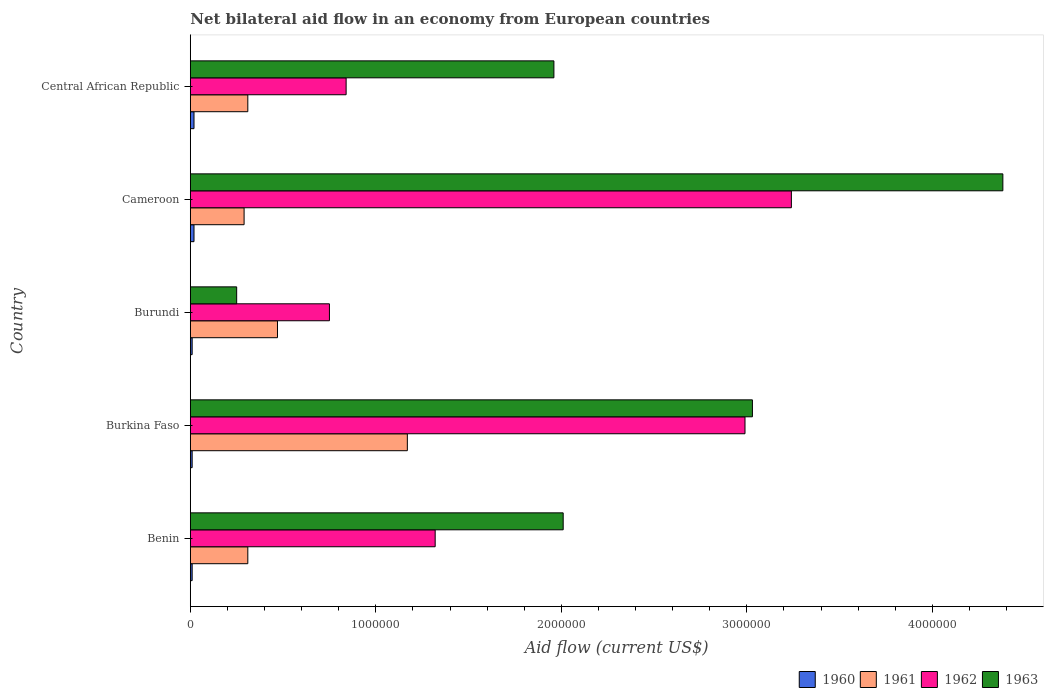How many groups of bars are there?
Keep it short and to the point. 5. Are the number of bars on each tick of the Y-axis equal?
Give a very brief answer. Yes. How many bars are there on the 2nd tick from the top?
Offer a terse response. 4. How many bars are there on the 1st tick from the bottom?
Offer a terse response. 4. What is the label of the 1st group of bars from the top?
Offer a very short reply. Central African Republic. What is the net bilateral aid flow in 1963 in Central African Republic?
Ensure brevity in your answer.  1.96e+06. In which country was the net bilateral aid flow in 1961 maximum?
Keep it short and to the point. Burkina Faso. In which country was the net bilateral aid flow in 1961 minimum?
Provide a succinct answer. Cameroon. What is the total net bilateral aid flow in 1961 in the graph?
Your answer should be very brief. 2.55e+06. What is the difference between the net bilateral aid flow in 1963 in Benin and that in Burundi?
Make the answer very short. 1.76e+06. What is the difference between the net bilateral aid flow in 1961 in Benin and the net bilateral aid flow in 1963 in Central African Republic?
Offer a very short reply. -1.65e+06. What is the average net bilateral aid flow in 1962 per country?
Your answer should be compact. 1.83e+06. What is the ratio of the net bilateral aid flow in 1962 in Benin to that in Cameroon?
Offer a terse response. 0.41. Is the net bilateral aid flow in 1960 in Benin less than that in Cameroon?
Give a very brief answer. Yes. Is the difference between the net bilateral aid flow in 1963 in Benin and Burkina Faso greater than the difference between the net bilateral aid flow in 1960 in Benin and Burkina Faso?
Offer a very short reply. No. What is the difference between the highest and the second highest net bilateral aid flow in 1963?
Provide a short and direct response. 1.35e+06. What is the difference between the highest and the lowest net bilateral aid flow in 1961?
Your answer should be compact. 8.80e+05. Is it the case that in every country, the sum of the net bilateral aid flow in 1963 and net bilateral aid flow in 1960 is greater than the sum of net bilateral aid flow in 1961 and net bilateral aid flow in 1962?
Your answer should be very brief. Yes. How many bars are there?
Your answer should be compact. 20. Are the values on the major ticks of X-axis written in scientific E-notation?
Give a very brief answer. No. Does the graph contain any zero values?
Provide a short and direct response. No. What is the title of the graph?
Provide a succinct answer. Net bilateral aid flow in an economy from European countries. What is the label or title of the X-axis?
Provide a succinct answer. Aid flow (current US$). What is the label or title of the Y-axis?
Offer a terse response. Country. What is the Aid flow (current US$) of 1961 in Benin?
Give a very brief answer. 3.10e+05. What is the Aid flow (current US$) of 1962 in Benin?
Make the answer very short. 1.32e+06. What is the Aid flow (current US$) of 1963 in Benin?
Ensure brevity in your answer.  2.01e+06. What is the Aid flow (current US$) of 1961 in Burkina Faso?
Provide a succinct answer. 1.17e+06. What is the Aid flow (current US$) in 1962 in Burkina Faso?
Your response must be concise. 2.99e+06. What is the Aid flow (current US$) of 1963 in Burkina Faso?
Offer a very short reply. 3.03e+06. What is the Aid flow (current US$) in 1962 in Burundi?
Provide a succinct answer. 7.50e+05. What is the Aid flow (current US$) of 1963 in Burundi?
Your response must be concise. 2.50e+05. What is the Aid flow (current US$) in 1962 in Cameroon?
Your response must be concise. 3.24e+06. What is the Aid flow (current US$) of 1963 in Cameroon?
Offer a very short reply. 4.38e+06. What is the Aid flow (current US$) of 1960 in Central African Republic?
Your answer should be very brief. 2.00e+04. What is the Aid flow (current US$) in 1962 in Central African Republic?
Your response must be concise. 8.40e+05. What is the Aid flow (current US$) of 1963 in Central African Republic?
Keep it short and to the point. 1.96e+06. Across all countries, what is the maximum Aid flow (current US$) of 1960?
Provide a short and direct response. 2.00e+04. Across all countries, what is the maximum Aid flow (current US$) in 1961?
Keep it short and to the point. 1.17e+06. Across all countries, what is the maximum Aid flow (current US$) of 1962?
Provide a succinct answer. 3.24e+06. Across all countries, what is the maximum Aid flow (current US$) in 1963?
Offer a terse response. 4.38e+06. Across all countries, what is the minimum Aid flow (current US$) of 1960?
Offer a very short reply. 10000. Across all countries, what is the minimum Aid flow (current US$) of 1961?
Provide a succinct answer. 2.90e+05. Across all countries, what is the minimum Aid flow (current US$) in 1962?
Your response must be concise. 7.50e+05. Across all countries, what is the minimum Aid flow (current US$) in 1963?
Make the answer very short. 2.50e+05. What is the total Aid flow (current US$) in 1961 in the graph?
Offer a very short reply. 2.55e+06. What is the total Aid flow (current US$) of 1962 in the graph?
Your answer should be very brief. 9.14e+06. What is the total Aid flow (current US$) in 1963 in the graph?
Provide a short and direct response. 1.16e+07. What is the difference between the Aid flow (current US$) in 1961 in Benin and that in Burkina Faso?
Make the answer very short. -8.60e+05. What is the difference between the Aid flow (current US$) in 1962 in Benin and that in Burkina Faso?
Offer a very short reply. -1.67e+06. What is the difference between the Aid flow (current US$) of 1963 in Benin and that in Burkina Faso?
Your answer should be very brief. -1.02e+06. What is the difference between the Aid flow (current US$) of 1960 in Benin and that in Burundi?
Give a very brief answer. 0. What is the difference between the Aid flow (current US$) in 1962 in Benin and that in Burundi?
Offer a very short reply. 5.70e+05. What is the difference between the Aid flow (current US$) in 1963 in Benin and that in Burundi?
Provide a succinct answer. 1.76e+06. What is the difference between the Aid flow (current US$) of 1961 in Benin and that in Cameroon?
Your answer should be very brief. 2.00e+04. What is the difference between the Aid flow (current US$) of 1962 in Benin and that in Cameroon?
Make the answer very short. -1.92e+06. What is the difference between the Aid flow (current US$) of 1963 in Benin and that in Cameroon?
Your answer should be very brief. -2.37e+06. What is the difference between the Aid flow (current US$) in 1960 in Benin and that in Central African Republic?
Make the answer very short. -10000. What is the difference between the Aid flow (current US$) in 1963 in Benin and that in Central African Republic?
Offer a very short reply. 5.00e+04. What is the difference between the Aid flow (current US$) in 1962 in Burkina Faso and that in Burundi?
Make the answer very short. 2.24e+06. What is the difference between the Aid flow (current US$) in 1963 in Burkina Faso and that in Burundi?
Offer a terse response. 2.78e+06. What is the difference between the Aid flow (current US$) of 1960 in Burkina Faso and that in Cameroon?
Offer a terse response. -10000. What is the difference between the Aid flow (current US$) of 1961 in Burkina Faso and that in Cameroon?
Offer a very short reply. 8.80e+05. What is the difference between the Aid flow (current US$) in 1962 in Burkina Faso and that in Cameroon?
Offer a terse response. -2.50e+05. What is the difference between the Aid flow (current US$) in 1963 in Burkina Faso and that in Cameroon?
Offer a terse response. -1.35e+06. What is the difference between the Aid flow (current US$) in 1960 in Burkina Faso and that in Central African Republic?
Provide a short and direct response. -10000. What is the difference between the Aid flow (current US$) of 1961 in Burkina Faso and that in Central African Republic?
Offer a very short reply. 8.60e+05. What is the difference between the Aid flow (current US$) in 1962 in Burkina Faso and that in Central African Republic?
Make the answer very short. 2.15e+06. What is the difference between the Aid flow (current US$) of 1963 in Burkina Faso and that in Central African Republic?
Your answer should be compact. 1.07e+06. What is the difference between the Aid flow (current US$) in 1962 in Burundi and that in Cameroon?
Provide a succinct answer. -2.49e+06. What is the difference between the Aid flow (current US$) in 1963 in Burundi and that in Cameroon?
Your answer should be compact. -4.13e+06. What is the difference between the Aid flow (current US$) of 1960 in Burundi and that in Central African Republic?
Make the answer very short. -10000. What is the difference between the Aid flow (current US$) in 1961 in Burundi and that in Central African Republic?
Provide a succinct answer. 1.60e+05. What is the difference between the Aid flow (current US$) in 1963 in Burundi and that in Central African Republic?
Ensure brevity in your answer.  -1.71e+06. What is the difference between the Aid flow (current US$) of 1960 in Cameroon and that in Central African Republic?
Provide a succinct answer. 0. What is the difference between the Aid flow (current US$) of 1962 in Cameroon and that in Central African Republic?
Offer a very short reply. 2.40e+06. What is the difference between the Aid flow (current US$) of 1963 in Cameroon and that in Central African Republic?
Keep it short and to the point. 2.42e+06. What is the difference between the Aid flow (current US$) of 1960 in Benin and the Aid flow (current US$) of 1961 in Burkina Faso?
Offer a very short reply. -1.16e+06. What is the difference between the Aid flow (current US$) of 1960 in Benin and the Aid flow (current US$) of 1962 in Burkina Faso?
Make the answer very short. -2.98e+06. What is the difference between the Aid flow (current US$) of 1960 in Benin and the Aid flow (current US$) of 1963 in Burkina Faso?
Provide a succinct answer. -3.02e+06. What is the difference between the Aid flow (current US$) in 1961 in Benin and the Aid flow (current US$) in 1962 in Burkina Faso?
Keep it short and to the point. -2.68e+06. What is the difference between the Aid flow (current US$) in 1961 in Benin and the Aid flow (current US$) in 1963 in Burkina Faso?
Make the answer very short. -2.72e+06. What is the difference between the Aid flow (current US$) in 1962 in Benin and the Aid flow (current US$) in 1963 in Burkina Faso?
Make the answer very short. -1.71e+06. What is the difference between the Aid flow (current US$) of 1960 in Benin and the Aid flow (current US$) of 1961 in Burundi?
Your response must be concise. -4.60e+05. What is the difference between the Aid flow (current US$) of 1960 in Benin and the Aid flow (current US$) of 1962 in Burundi?
Offer a terse response. -7.40e+05. What is the difference between the Aid flow (current US$) of 1961 in Benin and the Aid flow (current US$) of 1962 in Burundi?
Provide a succinct answer. -4.40e+05. What is the difference between the Aid flow (current US$) of 1962 in Benin and the Aid flow (current US$) of 1963 in Burundi?
Provide a short and direct response. 1.07e+06. What is the difference between the Aid flow (current US$) in 1960 in Benin and the Aid flow (current US$) in 1961 in Cameroon?
Keep it short and to the point. -2.80e+05. What is the difference between the Aid flow (current US$) in 1960 in Benin and the Aid flow (current US$) in 1962 in Cameroon?
Your answer should be very brief. -3.23e+06. What is the difference between the Aid flow (current US$) of 1960 in Benin and the Aid flow (current US$) of 1963 in Cameroon?
Make the answer very short. -4.37e+06. What is the difference between the Aid flow (current US$) of 1961 in Benin and the Aid flow (current US$) of 1962 in Cameroon?
Provide a short and direct response. -2.93e+06. What is the difference between the Aid flow (current US$) in 1961 in Benin and the Aid flow (current US$) in 1963 in Cameroon?
Offer a terse response. -4.07e+06. What is the difference between the Aid flow (current US$) of 1962 in Benin and the Aid flow (current US$) of 1963 in Cameroon?
Your answer should be compact. -3.06e+06. What is the difference between the Aid flow (current US$) in 1960 in Benin and the Aid flow (current US$) in 1961 in Central African Republic?
Your answer should be compact. -3.00e+05. What is the difference between the Aid flow (current US$) of 1960 in Benin and the Aid flow (current US$) of 1962 in Central African Republic?
Ensure brevity in your answer.  -8.30e+05. What is the difference between the Aid flow (current US$) of 1960 in Benin and the Aid flow (current US$) of 1963 in Central African Republic?
Make the answer very short. -1.95e+06. What is the difference between the Aid flow (current US$) of 1961 in Benin and the Aid flow (current US$) of 1962 in Central African Republic?
Your answer should be compact. -5.30e+05. What is the difference between the Aid flow (current US$) in 1961 in Benin and the Aid flow (current US$) in 1963 in Central African Republic?
Make the answer very short. -1.65e+06. What is the difference between the Aid flow (current US$) of 1962 in Benin and the Aid flow (current US$) of 1963 in Central African Republic?
Offer a terse response. -6.40e+05. What is the difference between the Aid flow (current US$) in 1960 in Burkina Faso and the Aid flow (current US$) in 1961 in Burundi?
Provide a short and direct response. -4.60e+05. What is the difference between the Aid flow (current US$) in 1960 in Burkina Faso and the Aid flow (current US$) in 1962 in Burundi?
Provide a short and direct response. -7.40e+05. What is the difference between the Aid flow (current US$) of 1960 in Burkina Faso and the Aid flow (current US$) of 1963 in Burundi?
Offer a very short reply. -2.40e+05. What is the difference between the Aid flow (current US$) of 1961 in Burkina Faso and the Aid flow (current US$) of 1962 in Burundi?
Offer a terse response. 4.20e+05. What is the difference between the Aid flow (current US$) in 1961 in Burkina Faso and the Aid flow (current US$) in 1963 in Burundi?
Your answer should be very brief. 9.20e+05. What is the difference between the Aid flow (current US$) of 1962 in Burkina Faso and the Aid flow (current US$) of 1963 in Burundi?
Your answer should be very brief. 2.74e+06. What is the difference between the Aid flow (current US$) in 1960 in Burkina Faso and the Aid flow (current US$) in 1961 in Cameroon?
Your response must be concise. -2.80e+05. What is the difference between the Aid flow (current US$) of 1960 in Burkina Faso and the Aid flow (current US$) of 1962 in Cameroon?
Your answer should be very brief. -3.23e+06. What is the difference between the Aid flow (current US$) in 1960 in Burkina Faso and the Aid flow (current US$) in 1963 in Cameroon?
Keep it short and to the point. -4.37e+06. What is the difference between the Aid flow (current US$) of 1961 in Burkina Faso and the Aid flow (current US$) of 1962 in Cameroon?
Offer a terse response. -2.07e+06. What is the difference between the Aid flow (current US$) in 1961 in Burkina Faso and the Aid flow (current US$) in 1963 in Cameroon?
Give a very brief answer. -3.21e+06. What is the difference between the Aid flow (current US$) in 1962 in Burkina Faso and the Aid flow (current US$) in 1963 in Cameroon?
Offer a very short reply. -1.39e+06. What is the difference between the Aid flow (current US$) in 1960 in Burkina Faso and the Aid flow (current US$) in 1961 in Central African Republic?
Provide a short and direct response. -3.00e+05. What is the difference between the Aid flow (current US$) in 1960 in Burkina Faso and the Aid flow (current US$) in 1962 in Central African Republic?
Make the answer very short. -8.30e+05. What is the difference between the Aid flow (current US$) in 1960 in Burkina Faso and the Aid flow (current US$) in 1963 in Central African Republic?
Make the answer very short. -1.95e+06. What is the difference between the Aid flow (current US$) of 1961 in Burkina Faso and the Aid flow (current US$) of 1963 in Central African Republic?
Offer a terse response. -7.90e+05. What is the difference between the Aid flow (current US$) in 1962 in Burkina Faso and the Aid flow (current US$) in 1963 in Central African Republic?
Your answer should be very brief. 1.03e+06. What is the difference between the Aid flow (current US$) in 1960 in Burundi and the Aid flow (current US$) in 1961 in Cameroon?
Offer a terse response. -2.80e+05. What is the difference between the Aid flow (current US$) in 1960 in Burundi and the Aid flow (current US$) in 1962 in Cameroon?
Provide a short and direct response. -3.23e+06. What is the difference between the Aid flow (current US$) in 1960 in Burundi and the Aid flow (current US$) in 1963 in Cameroon?
Provide a short and direct response. -4.37e+06. What is the difference between the Aid flow (current US$) of 1961 in Burundi and the Aid flow (current US$) of 1962 in Cameroon?
Offer a very short reply. -2.77e+06. What is the difference between the Aid flow (current US$) of 1961 in Burundi and the Aid flow (current US$) of 1963 in Cameroon?
Provide a short and direct response. -3.91e+06. What is the difference between the Aid flow (current US$) of 1962 in Burundi and the Aid flow (current US$) of 1963 in Cameroon?
Your answer should be compact. -3.63e+06. What is the difference between the Aid flow (current US$) of 1960 in Burundi and the Aid flow (current US$) of 1961 in Central African Republic?
Provide a short and direct response. -3.00e+05. What is the difference between the Aid flow (current US$) of 1960 in Burundi and the Aid flow (current US$) of 1962 in Central African Republic?
Provide a succinct answer. -8.30e+05. What is the difference between the Aid flow (current US$) in 1960 in Burundi and the Aid flow (current US$) in 1963 in Central African Republic?
Provide a short and direct response. -1.95e+06. What is the difference between the Aid flow (current US$) of 1961 in Burundi and the Aid flow (current US$) of 1962 in Central African Republic?
Provide a short and direct response. -3.70e+05. What is the difference between the Aid flow (current US$) of 1961 in Burundi and the Aid flow (current US$) of 1963 in Central African Republic?
Offer a very short reply. -1.49e+06. What is the difference between the Aid flow (current US$) in 1962 in Burundi and the Aid flow (current US$) in 1963 in Central African Republic?
Give a very brief answer. -1.21e+06. What is the difference between the Aid flow (current US$) in 1960 in Cameroon and the Aid flow (current US$) in 1961 in Central African Republic?
Give a very brief answer. -2.90e+05. What is the difference between the Aid flow (current US$) in 1960 in Cameroon and the Aid flow (current US$) in 1962 in Central African Republic?
Offer a very short reply. -8.20e+05. What is the difference between the Aid flow (current US$) in 1960 in Cameroon and the Aid flow (current US$) in 1963 in Central African Republic?
Ensure brevity in your answer.  -1.94e+06. What is the difference between the Aid flow (current US$) of 1961 in Cameroon and the Aid flow (current US$) of 1962 in Central African Republic?
Offer a very short reply. -5.50e+05. What is the difference between the Aid flow (current US$) of 1961 in Cameroon and the Aid flow (current US$) of 1963 in Central African Republic?
Ensure brevity in your answer.  -1.67e+06. What is the difference between the Aid flow (current US$) of 1962 in Cameroon and the Aid flow (current US$) of 1963 in Central African Republic?
Make the answer very short. 1.28e+06. What is the average Aid flow (current US$) in 1960 per country?
Your answer should be compact. 1.40e+04. What is the average Aid flow (current US$) in 1961 per country?
Your answer should be very brief. 5.10e+05. What is the average Aid flow (current US$) of 1962 per country?
Make the answer very short. 1.83e+06. What is the average Aid flow (current US$) of 1963 per country?
Keep it short and to the point. 2.33e+06. What is the difference between the Aid flow (current US$) in 1960 and Aid flow (current US$) in 1961 in Benin?
Give a very brief answer. -3.00e+05. What is the difference between the Aid flow (current US$) of 1960 and Aid flow (current US$) of 1962 in Benin?
Your response must be concise. -1.31e+06. What is the difference between the Aid flow (current US$) in 1960 and Aid flow (current US$) in 1963 in Benin?
Keep it short and to the point. -2.00e+06. What is the difference between the Aid flow (current US$) of 1961 and Aid flow (current US$) of 1962 in Benin?
Give a very brief answer. -1.01e+06. What is the difference between the Aid flow (current US$) of 1961 and Aid flow (current US$) of 1963 in Benin?
Your answer should be compact. -1.70e+06. What is the difference between the Aid flow (current US$) of 1962 and Aid flow (current US$) of 1963 in Benin?
Offer a very short reply. -6.90e+05. What is the difference between the Aid flow (current US$) of 1960 and Aid flow (current US$) of 1961 in Burkina Faso?
Offer a terse response. -1.16e+06. What is the difference between the Aid flow (current US$) in 1960 and Aid flow (current US$) in 1962 in Burkina Faso?
Make the answer very short. -2.98e+06. What is the difference between the Aid flow (current US$) in 1960 and Aid flow (current US$) in 1963 in Burkina Faso?
Offer a very short reply. -3.02e+06. What is the difference between the Aid flow (current US$) in 1961 and Aid flow (current US$) in 1962 in Burkina Faso?
Provide a short and direct response. -1.82e+06. What is the difference between the Aid flow (current US$) of 1961 and Aid flow (current US$) of 1963 in Burkina Faso?
Give a very brief answer. -1.86e+06. What is the difference between the Aid flow (current US$) in 1960 and Aid flow (current US$) in 1961 in Burundi?
Make the answer very short. -4.60e+05. What is the difference between the Aid flow (current US$) in 1960 and Aid flow (current US$) in 1962 in Burundi?
Ensure brevity in your answer.  -7.40e+05. What is the difference between the Aid flow (current US$) in 1961 and Aid flow (current US$) in 1962 in Burundi?
Provide a short and direct response. -2.80e+05. What is the difference between the Aid flow (current US$) in 1961 and Aid flow (current US$) in 1963 in Burundi?
Your response must be concise. 2.20e+05. What is the difference between the Aid flow (current US$) of 1962 and Aid flow (current US$) of 1963 in Burundi?
Keep it short and to the point. 5.00e+05. What is the difference between the Aid flow (current US$) of 1960 and Aid flow (current US$) of 1961 in Cameroon?
Your answer should be very brief. -2.70e+05. What is the difference between the Aid flow (current US$) in 1960 and Aid flow (current US$) in 1962 in Cameroon?
Ensure brevity in your answer.  -3.22e+06. What is the difference between the Aid flow (current US$) of 1960 and Aid flow (current US$) of 1963 in Cameroon?
Provide a succinct answer. -4.36e+06. What is the difference between the Aid flow (current US$) in 1961 and Aid flow (current US$) in 1962 in Cameroon?
Give a very brief answer. -2.95e+06. What is the difference between the Aid flow (current US$) in 1961 and Aid flow (current US$) in 1963 in Cameroon?
Ensure brevity in your answer.  -4.09e+06. What is the difference between the Aid flow (current US$) in 1962 and Aid flow (current US$) in 1963 in Cameroon?
Offer a terse response. -1.14e+06. What is the difference between the Aid flow (current US$) in 1960 and Aid flow (current US$) in 1961 in Central African Republic?
Provide a short and direct response. -2.90e+05. What is the difference between the Aid flow (current US$) in 1960 and Aid flow (current US$) in 1962 in Central African Republic?
Provide a succinct answer. -8.20e+05. What is the difference between the Aid flow (current US$) in 1960 and Aid flow (current US$) in 1963 in Central African Republic?
Provide a short and direct response. -1.94e+06. What is the difference between the Aid flow (current US$) of 1961 and Aid flow (current US$) of 1962 in Central African Republic?
Make the answer very short. -5.30e+05. What is the difference between the Aid flow (current US$) of 1961 and Aid flow (current US$) of 1963 in Central African Republic?
Provide a short and direct response. -1.65e+06. What is the difference between the Aid flow (current US$) of 1962 and Aid flow (current US$) of 1963 in Central African Republic?
Give a very brief answer. -1.12e+06. What is the ratio of the Aid flow (current US$) of 1961 in Benin to that in Burkina Faso?
Offer a terse response. 0.27. What is the ratio of the Aid flow (current US$) of 1962 in Benin to that in Burkina Faso?
Your answer should be compact. 0.44. What is the ratio of the Aid flow (current US$) of 1963 in Benin to that in Burkina Faso?
Offer a terse response. 0.66. What is the ratio of the Aid flow (current US$) in 1961 in Benin to that in Burundi?
Your response must be concise. 0.66. What is the ratio of the Aid flow (current US$) of 1962 in Benin to that in Burundi?
Keep it short and to the point. 1.76. What is the ratio of the Aid flow (current US$) of 1963 in Benin to that in Burundi?
Make the answer very short. 8.04. What is the ratio of the Aid flow (current US$) in 1960 in Benin to that in Cameroon?
Your answer should be very brief. 0.5. What is the ratio of the Aid flow (current US$) in 1961 in Benin to that in Cameroon?
Provide a short and direct response. 1.07. What is the ratio of the Aid flow (current US$) in 1962 in Benin to that in Cameroon?
Provide a succinct answer. 0.41. What is the ratio of the Aid flow (current US$) in 1963 in Benin to that in Cameroon?
Your answer should be very brief. 0.46. What is the ratio of the Aid flow (current US$) of 1960 in Benin to that in Central African Republic?
Ensure brevity in your answer.  0.5. What is the ratio of the Aid flow (current US$) of 1962 in Benin to that in Central African Republic?
Ensure brevity in your answer.  1.57. What is the ratio of the Aid flow (current US$) in 1963 in Benin to that in Central African Republic?
Provide a succinct answer. 1.03. What is the ratio of the Aid flow (current US$) in 1961 in Burkina Faso to that in Burundi?
Your response must be concise. 2.49. What is the ratio of the Aid flow (current US$) of 1962 in Burkina Faso to that in Burundi?
Your answer should be compact. 3.99. What is the ratio of the Aid flow (current US$) in 1963 in Burkina Faso to that in Burundi?
Provide a succinct answer. 12.12. What is the ratio of the Aid flow (current US$) in 1961 in Burkina Faso to that in Cameroon?
Ensure brevity in your answer.  4.03. What is the ratio of the Aid flow (current US$) in 1962 in Burkina Faso to that in Cameroon?
Keep it short and to the point. 0.92. What is the ratio of the Aid flow (current US$) in 1963 in Burkina Faso to that in Cameroon?
Give a very brief answer. 0.69. What is the ratio of the Aid flow (current US$) of 1960 in Burkina Faso to that in Central African Republic?
Keep it short and to the point. 0.5. What is the ratio of the Aid flow (current US$) of 1961 in Burkina Faso to that in Central African Republic?
Keep it short and to the point. 3.77. What is the ratio of the Aid flow (current US$) of 1962 in Burkina Faso to that in Central African Republic?
Your response must be concise. 3.56. What is the ratio of the Aid flow (current US$) in 1963 in Burkina Faso to that in Central African Republic?
Provide a short and direct response. 1.55. What is the ratio of the Aid flow (current US$) in 1961 in Burundi to that in Cameroon?
Offer a very short reply. 1.62. What is the ratio of the Aid flow (current US$) of 1962 in Burundi to that in Cameroon?
Offer a terse response. 0.23. What is the ratio of the Aid flow (current US$) of 1963 in Burundi to that in Cameroon?
Your response must be concise. 0.06. What is the ratio of the Aid flow (current US$) in 1960 in Burundi to that in Central African Republic?
Ensure brevity in your answer.  0.5. What is the ratio of the Aid flow (current US$) in 1961 in Burundi to that in Central African Republic?
Ensure brevity in your answer.  1.52. What is the ratio of the Aid flow (current US$) in 1962 in Burundi to that in Central African Republic?
Your response must be concise. 0.89. What is the ratio of the Aid flow (current US$) of 1963 in Burundi to that in Central African Republic?
Offer a very short reply. 0.13. What is the ratio of the Aid flow (current US$) of 1961 in Cameroon to that in Central African Republic?
Ensure brevity in your answer.  0.94. What is the ratio of the Aid flow (current US$) in 1962 in Cameroon to that in Central African Republic?
Give a very brief answer. 3.86. What is the ratio of the Aid flow (current US$) in 1963 in Cameroon to that in Central African Republic?
Your answer should be compact. 2.23. What is the difference between the highest and the second highest Aid flow (current US$) in 1963?
Ensure brevity in your answer.  1.35e+06. What is the difference between the highest and the lowest Aid flow (current US$) of 1960?
Provide a short and direct response. 10000. What is the difference between the highest and the lowest Aid flow (current US$) in 1961?
Your answer should be compact. 8.80e+05. What is the difference between the highest and the lowest Aid flow (current US$) in 1962?
Ensure brevity in your answer.  2.49e+06. What is the difference between the highest and the lowest Aid flow (current US$) of 1963?
Offer a terse response. 4.13e+06. 